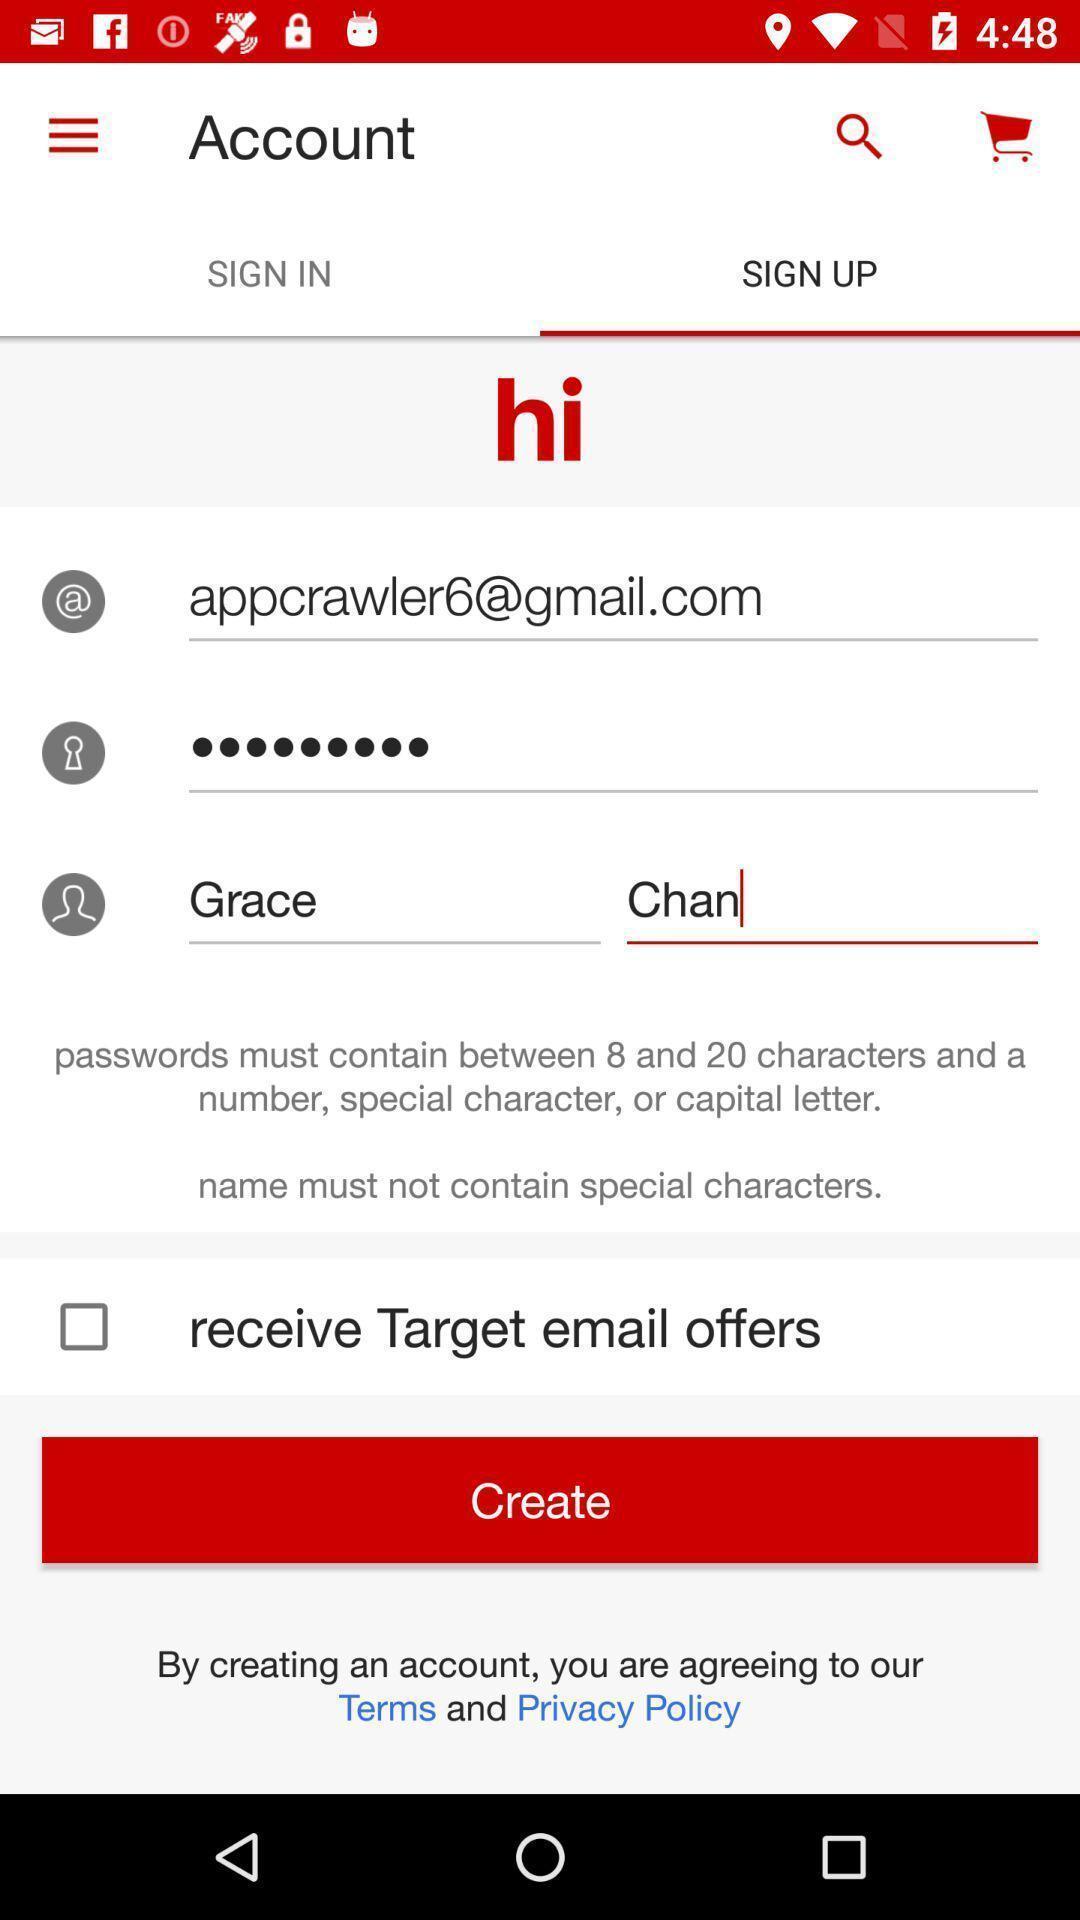Please provide a description for this image. Sign-in page. 